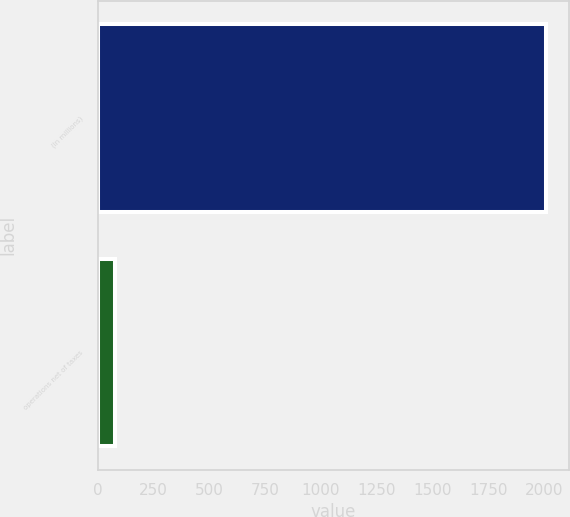Convert chart to OTSL. <chart><loc_0><loc_0><loc_500><loc_500><bar_chart><fcel>(In millions)<fcel>operations net of taxes<nl><fcel>2011<fcel>76<nl></chart> 